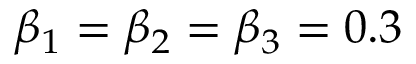<formula> <loc_0><loc_0><loc_500><loc_500>\beta _ { 1 } = \beta _ { 2 } = \beta _ { 3 } = 0 . 3</formula> 